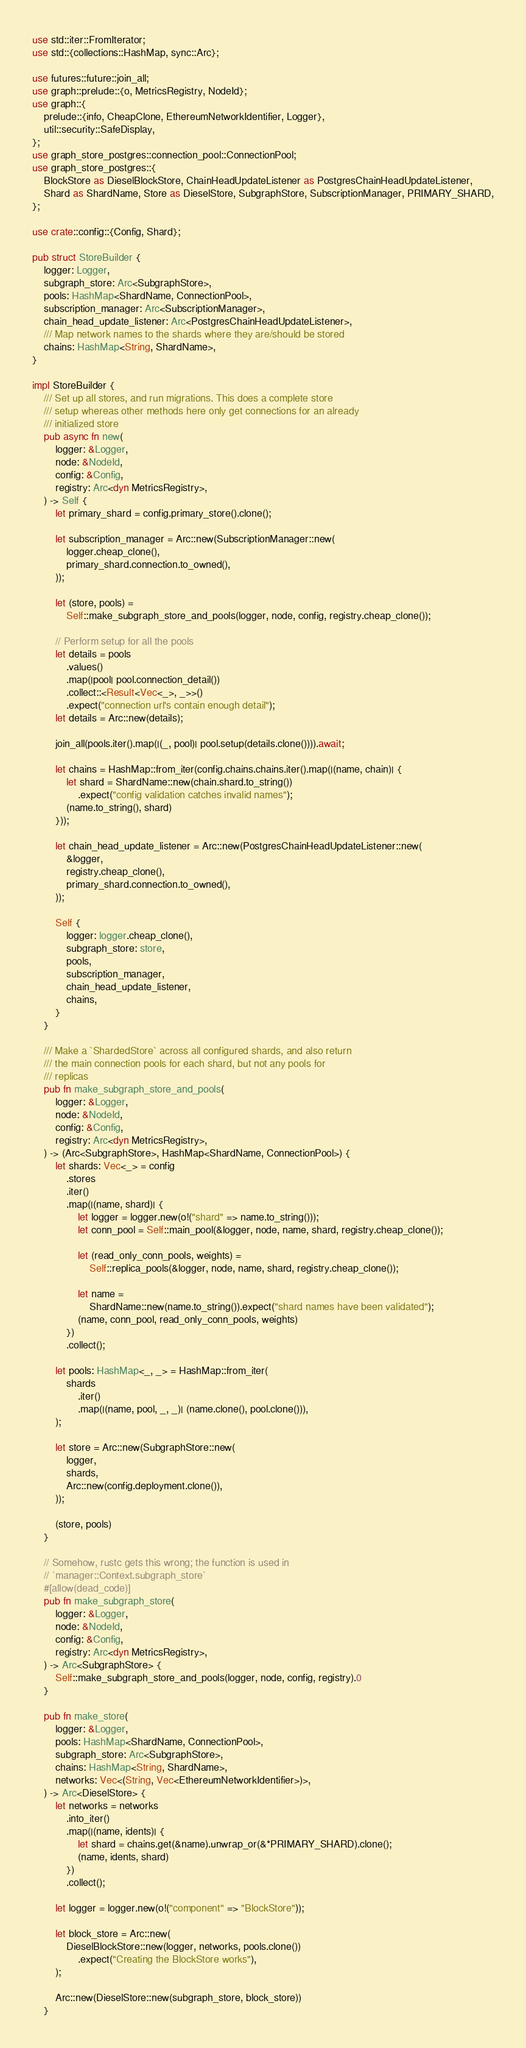Convert code to text. <code><loc_0><loc_0><loc_500><loc_500><_Rust_>use std::iter::FromIterator;
use std::{collections::HashMap, sync::Arc};

use futures::future::join_all;
use graph::prelude::{o, MetricsRegistry, NodeId};
use graph::{
    prelude::{info, CheapClone, EthereumNetworkIdentifier, Logger},
    util::security::SafeDisplay,
};
use graph_store_postgres::connection_pool::ConnectionPool;
use graph_store_postgres::{
    BlockStore as DieselBlockStore, ChainHeadUpdateListener as PostgresChainHeadUpdateListener,
    Shard as ShardName, Store as DieselStore, SubgraphStore, SubscriptionManager, PRIMARY_SHARD,
};

use crate::config::{Config, Shard};

pub struct StoreBuilder {
    logger: Logger,
    subgraph_store: Arc<SubgraphStore>,
    pools: HashMap<ShardName, ConnectionPool>,
    subscription_manager: Arc<SubscriptionManager>,
    chain_head_update_listener: Arc<PostgresChainHeadUpdateListener>,
    /// Map network names to the shards where they are/should be stored
    chains: HashMap<String, ShardName>,
}

impl StoreBuilder {
    /// Set up all stores, and run migrations. This does a complete store
    /// setup whereas other methods here only get connections for an already
    /// initialized store
    pub async fn new(
        logger: &Logger,
        node: &NodeId,
        config: &Config,
        registry: Arc<dyn MetricsRegistry>,
    ) -> Self {
        let primary_shard = config.primary_store().clone();

        let subscription_manager = Arc::new(SubscriptionManager::new(
            logger.cheap_clone(),
            primary_shard.connection.to_owned(),
        ));

        let (store, pools) =
            Self::make_subgraph_store_and_pools(logger, node, config, registry.cheap_clone());

        // Perform setup for all the pools
        let details = pools
            .values()
            .map(|pool| pool.connection_detail())
            .collect::<Result<Vec<_>, _>>()
            .expect("connection url's contain enough detail");
        let details = Arc::new(details);

        join_all(pools.iter().map(|(_, pool)| pool.setup(details.clone()))).await;

        let chains = HashMap::from_iter(config.chains.chains.iter().map(|(name, chain)| {
            let shard = ShardName::new(chain.shard.to_string())
                .expect("config validation catches invalid names");
            (name.to_string(), shard)
        }));

        let chain_head_update_listener = Arc::new(PostgresChainHeadUpdateListener::new(
            &logger,
            registry.cheap_clone(),
            primary_shard.connection.to_owned(),
        ));

        Self {
            logger: logger.cheap_clone(),
            subgraph_store: store,
            pools,
            subscription_manager,
            chain_head_update_listener,
            chains,
        }
    }

    /// Make a `ShardedStore` across all configured shards, and also return
    /// the main connection pools for each shard, but not any pools for
    /// replicas
    pub fn make_subgraph_store_and_pools(
        logger: &Logger,
        node: &NodeId,
        config: &Config,
        registry: Arc<dyn MetricsRegistry>,
    ) -> (Arc<SubgraphStore>, HashMap<ShardName, ConnectionPool>) {
        let shards: Vec<_> = config
            .stores
            .iter()
            .map(|(name, shard)| {
                let logger = logger.new(o!("shard" => name.to_string()));
                let conn_pool = Self::main_pool(&logger, node, name, shard, registry.cheap_clone());

                let (read_only_conn_pools, weights) =
                    Self::replica_pools(&logger, node, name, shard, registry.cheap_clone());

                let name =
                    ShardName::new(name.to_string()).expect("shard names have been validated");
                (name, conn_pool, read_only_conn_pools, weights)
            })
            .collect();

        let pools: HashMap<_, _> = HashMap::from_iter(
            shards
                .iter()
                .map(|(name, pool, _, _)| (name.clone(), pool.clone())),
        );

        let store = Arc::new(SubgraphStore::new(
            logger,
            shards,
            Arc::new(config.deployment.clone()),
        ));

        (store, pools)
    }

    // Somehow, rustc gets this wrong; the function is used in
    // `manager::Context.subgraph_store`
    #[allow(dead_code)]
    pub fn make_subgraph_store(
        logger: &Logger,
        node: &NodeId,
        config: &Config,
        registry: Arc<dyn MetricsRegistry>,
    ) -> Arc<SubgraphStore> {
        Self::make_subgraph_store_and_pools(logger, node, config, registry).0
    }

    pub fn make_store(
        logger: &Logger,
        pools: HashMap<ShardName, ConnectionPool>,
        subgraph_store: Arc<SubgraphStore>,
        chains: HashMap<String, ShardName>,
        networks: Vec<(String, Vec<EthereumNetworkIdentifier>)>,
    ) -> Arc<DieselStore> {
        let networks = networks
            .into_iter()
            .map(|(name, idents)| {
                let shard = chains.get(&name).unwrap_or(&*PRIMARY_SHARD).clone();
                (name, idents, shard)
            })
            .collect();

        let logger = logger.new(o!("component" => "BlockStore"));

        let block_store = Arc::new(
            DieselBlockStore::new(logger, networks, pools.clone())
                .expect("Creating the BlockStore works"),
        );

        Arc::new(DieselStore::new(subgraph_store, block_store))
    }
</code> 